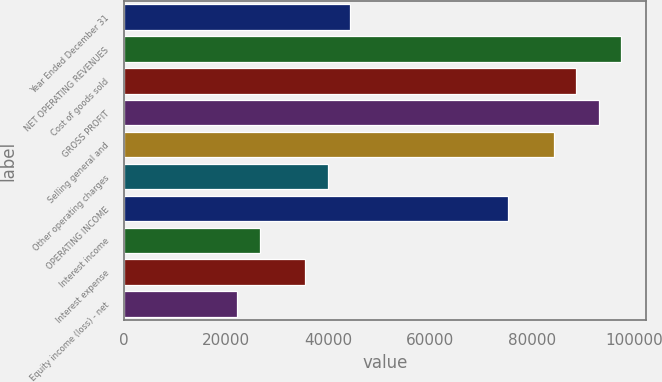<chart> <loc_0><loc_0><loc_500><loc_500><bar_chart><fcel>Year Ended December 31<fcel>NET OPERATING REVENUES<fcel>Cost of goods sold<fcel>GROSS PROFIT<fcel>Selling general and<fcel>Other operating charges<fcel>OPERATING INCOME<fcel>Interest income<fcel>Interest expense<fcel>Equity income (loss) - net<nl><fcel>44294<fcel>97444.7<fcel>88586.3<fcel>93015.5<fcel>84157<fcel>39864.7<fcel>75298.6<fcel>26577<fcel>35435.5<fcel>22147.8<nl></chart> 